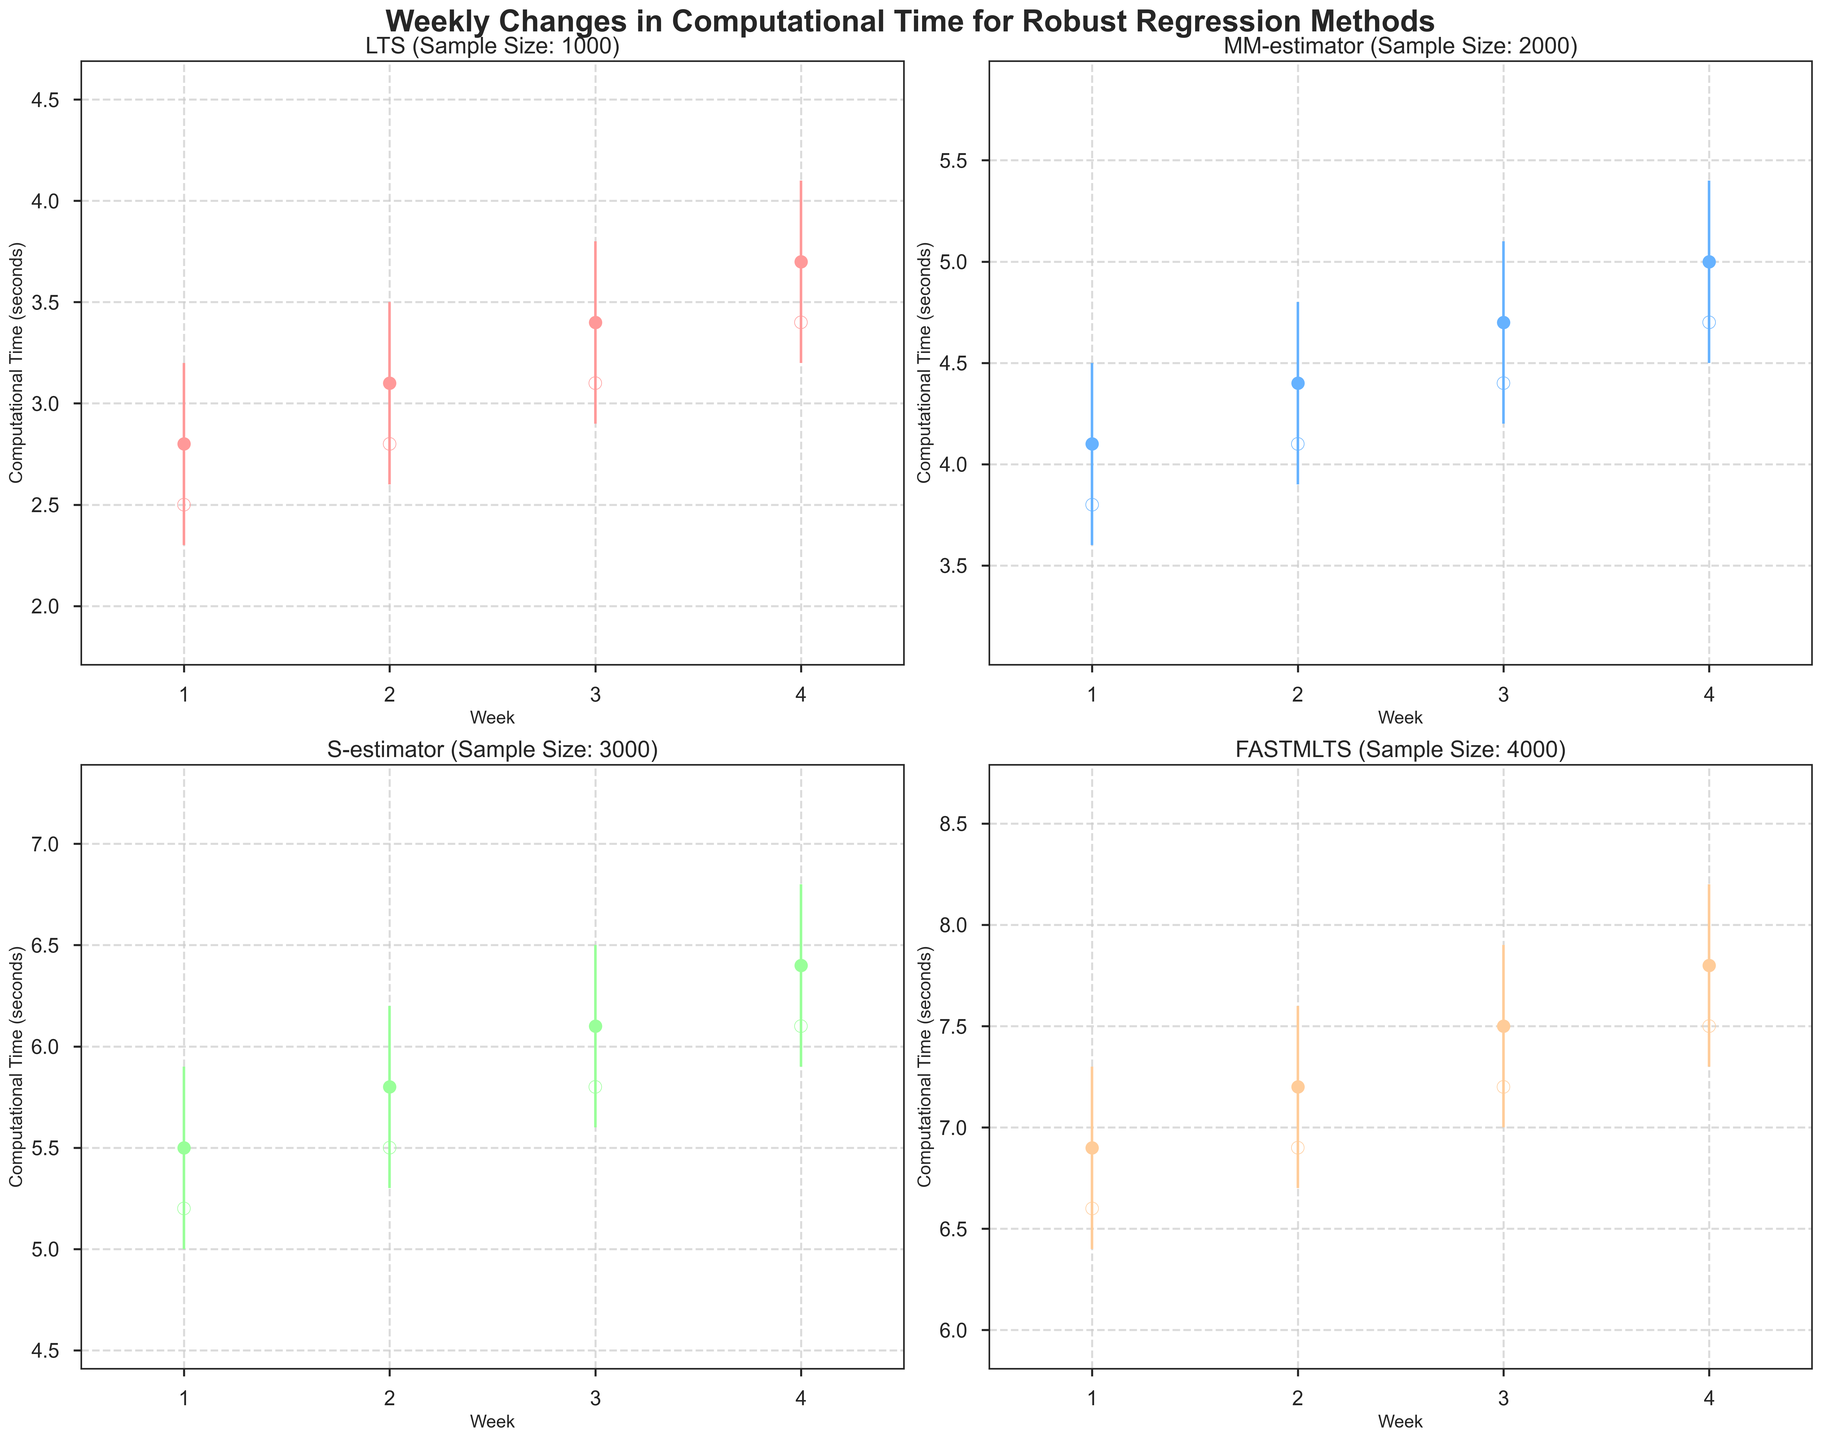What is the title of the figure? The title of the figure is prominently displayed at the top, and it reads "Weekly Changes in Computational Time for Robust Regression Methods".
Answer: Weekly Changes in Computational Time for Robust Regression Methods How are the weeks represented on the x-axis? The weeks are represented as numerical values (1, 2, 3, 4) on the x-axis in each subplot.
Answer: Numerical values 1, 2, 3, 4 Which method has the highest peak computational time in any week? By identifying the highest peaks in the charts, we see that the 'FASTMLTS' method reaches a high of 8.2 seconds.
Answer: FASTMLTS What is the closing computational time for the MM-estimator method in week 3? The closing computational time can be found by looking at the closing price marker (filled circle) for the MM-estimator method in week 3, which is at 4.7 seconds.
Answer: 4.7 seconds For the LTS method, did the computational time ever decrease over the weeks? Observing the line connecting the closing values for the LTS method, the computational time increases consistently from weeks 1 to 4, indicating no decrease.
Answer: No Which method showed the smallest range of computational times over any week? By comparing the ranges (high - low) for all methods, the 'LTS' method in week 1 has the smallest range, from 2.3 to 3.2 seconds.
Answer: LTS What is the difference in the closing computational times between week 1 and week 4 for the S-estimator method? The closing computational time for the S-estimator method is 5.5 seconds in week 1 and 6.4 seconds in week 4. The difference is 6.4 - 5.5 = 0.9 seconds.
Answer: 0.9 seconds How did the computational time change from week 1 to week 2 for FASTMLTS method? The FASTMLTS method's closing computational time increased from 6.9 seconds in week 1 to 7.2 seconds in week 2.
Answer: Increased Which method shows the steepest increase in computational time between any two consecutive weeks? Observing the changes in closing values for all methods, the 'FASTMLTS' method from week 1 to week 2 shows the steepest increase, from 6.9 to 7.2 seconds, an increase of 0.3 seconds.
Answer: FASTMLTS 